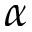Convert formula to latex. <formula><loc_0><loc_0><loc_500><loc_500>\alpha</formula> 